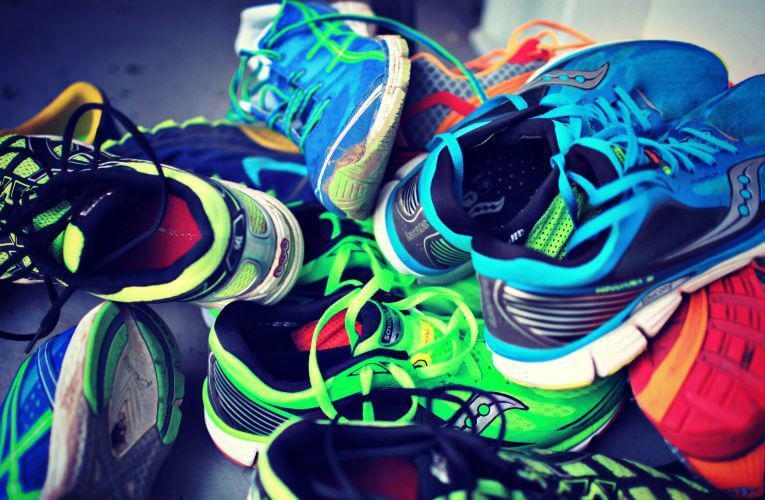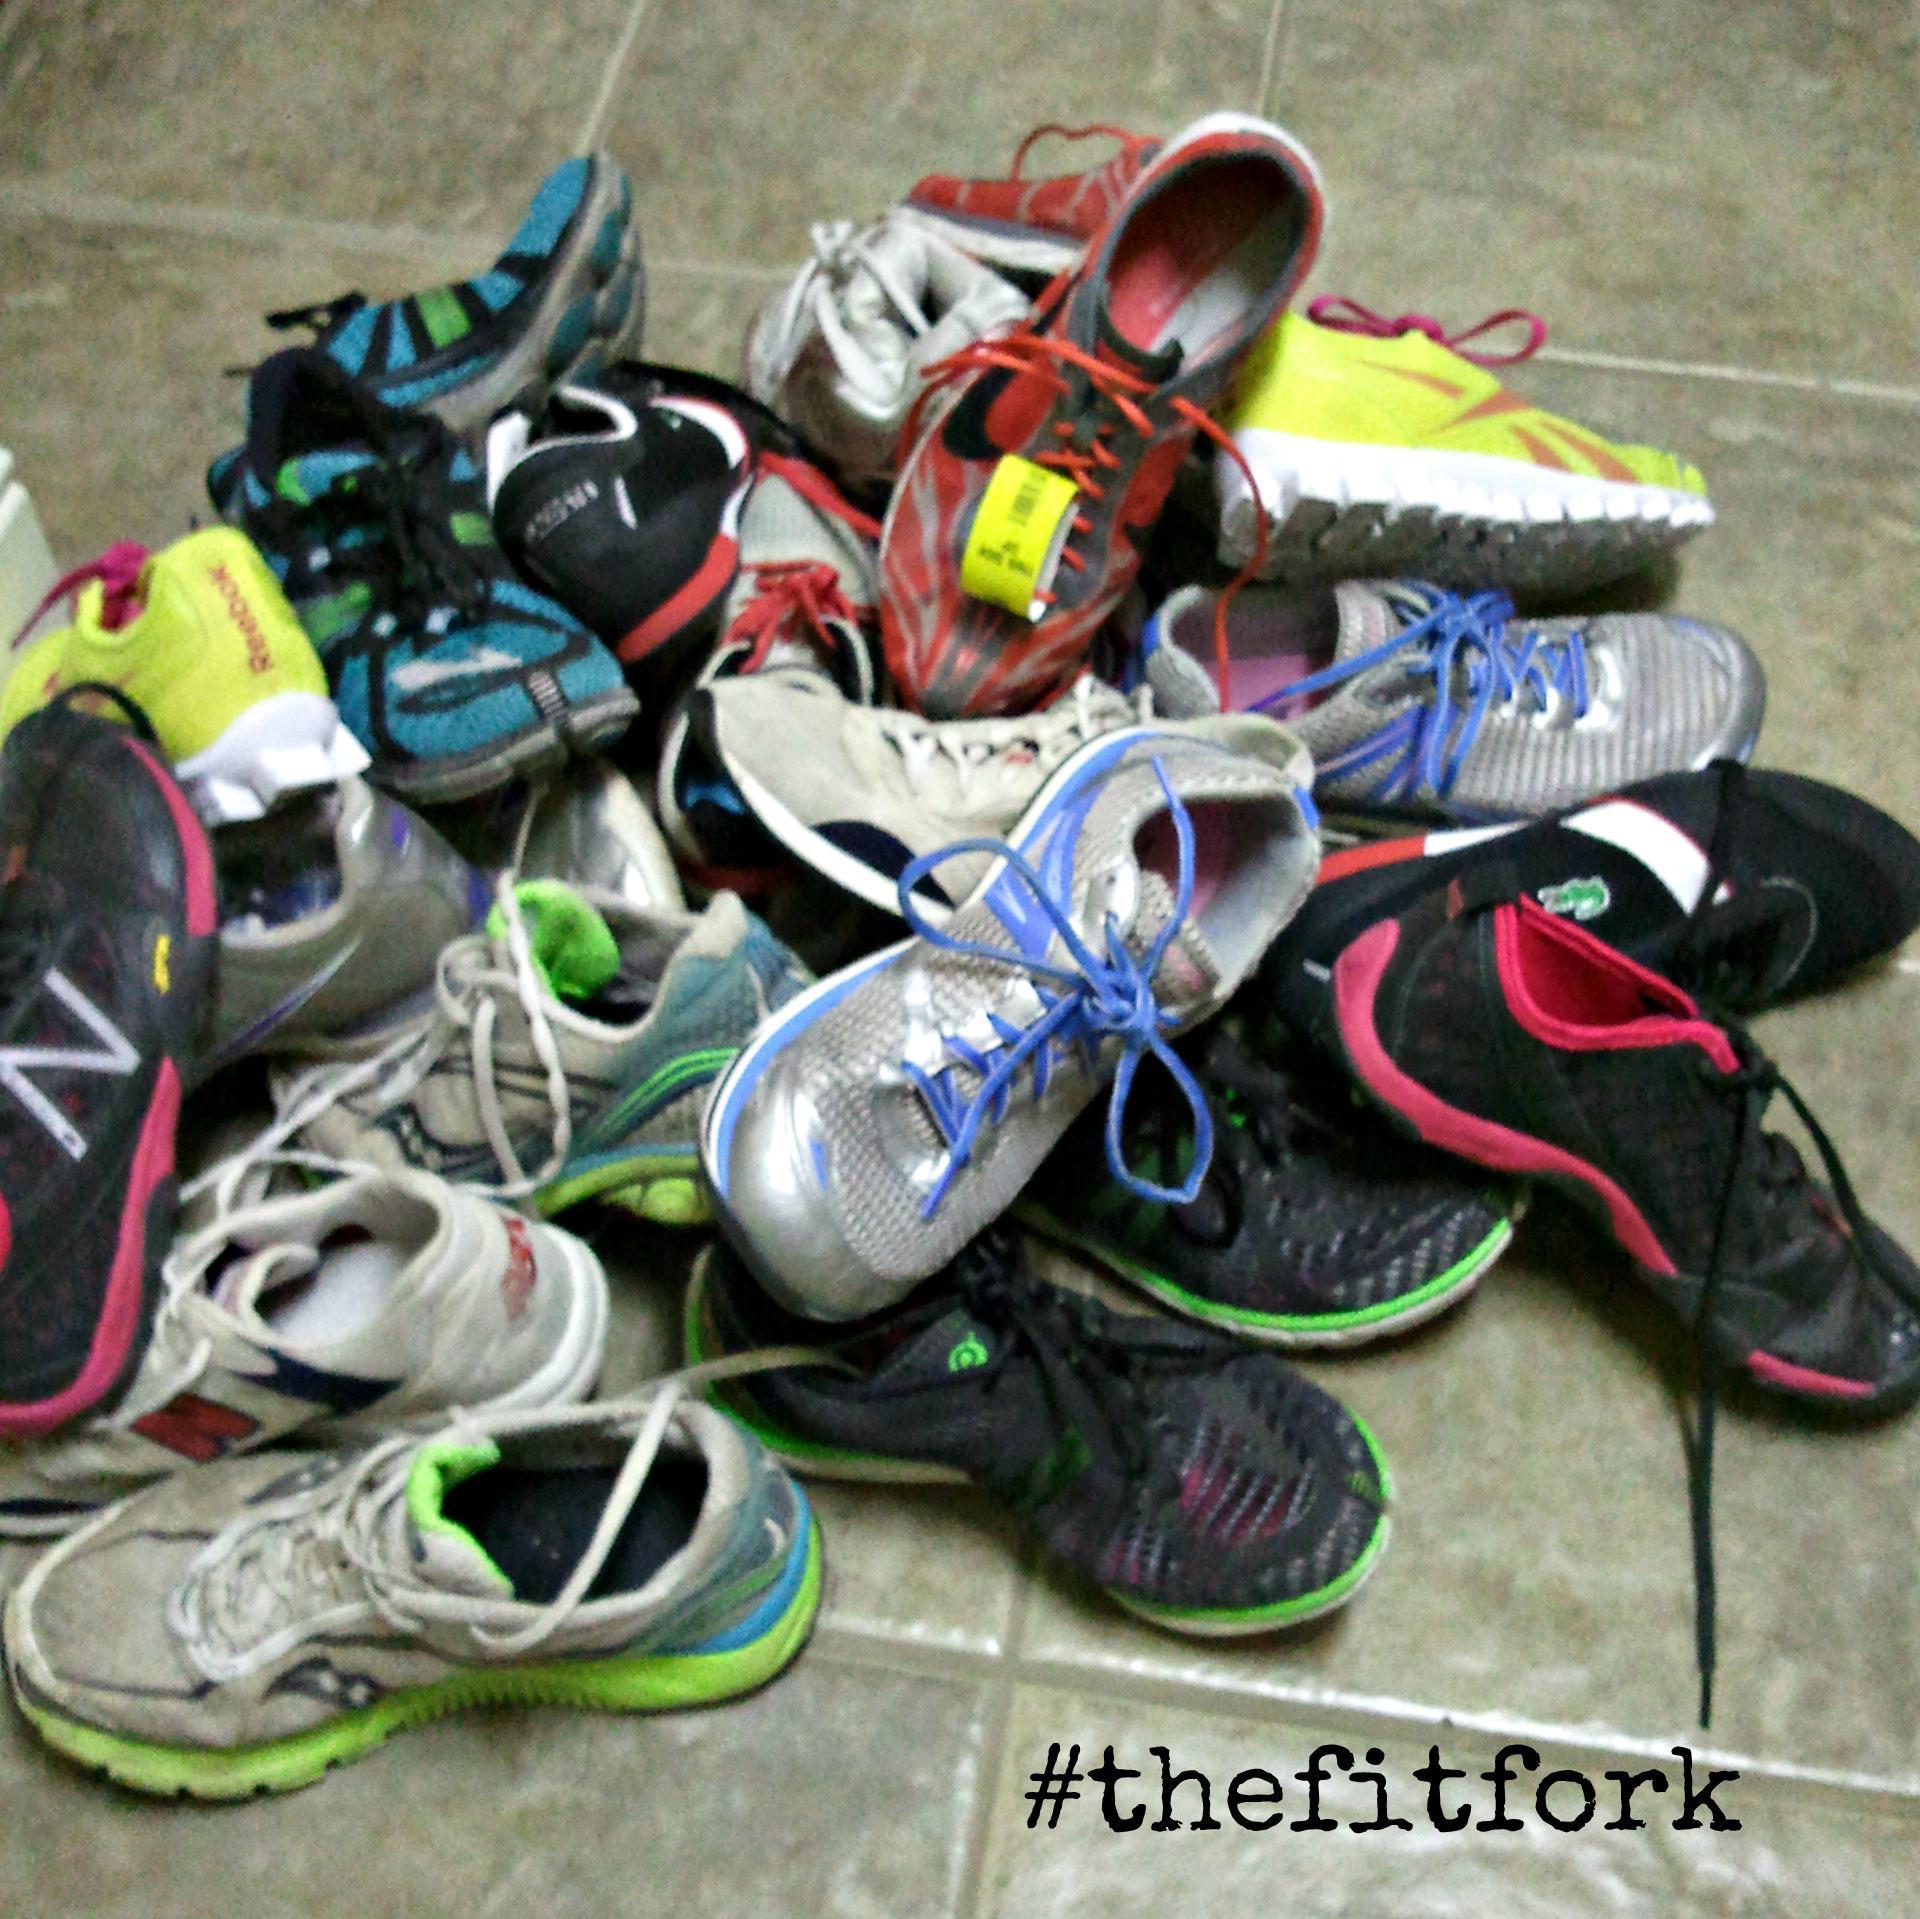The first image is the image on the left, the second image is the image on the right. Assess this claim about the two images: "At least 30 shoes are piled up and none are in neat rows.". Correct or not? Answer yes or no. Yes. The first image is the image on the left, the second image is the image on the right. Considering the images on both sides, is "There are piles of athletic shoes sitting on the floor in the center of the images." valid? Answer yes or no. Yes. 